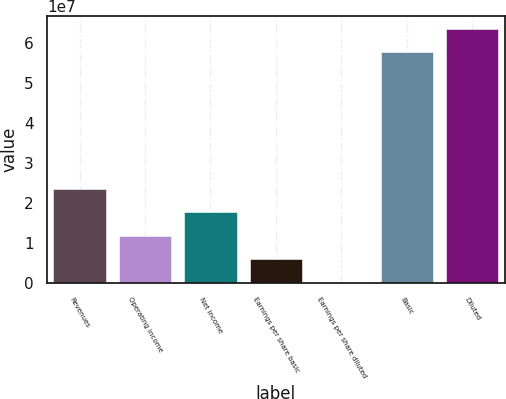Convert chart. <chart><loc_0><loc_0><loc_500><loc_500><bar_chart><fcel>Revenues<fcel>Operating income<fcel>Net income<fcel>Earnings per share basic<fcel>Earnings per share diluted<fcel>Basic<fcel>Diluted<nl><fcel>2.35629e+07<fcel>1.17815e+07<fcel>1.76722e+07<fcel>5.89073e+06<fcel>0.1<fcel>5.78197e+07<fcel>6.37105e+07<nl></chart> 